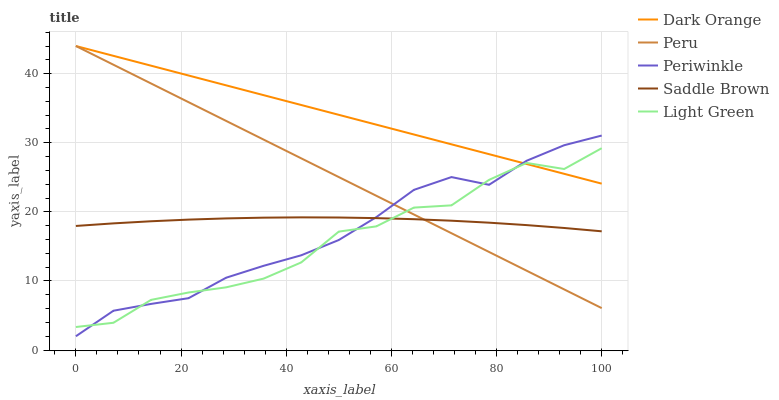Does Light Green have the minimum area under the curve?
Answer yes or no. Yes. Does Dark Orange have the maximum area under the curve?
Answer yes or no. Yes. Does Periwinkle have the minimum area under the curve?
Answer yes or no. No. Does Periwinkle have the maximum area under the curve?
Answer yes or no. No. Is Dark Orange the smoothest?
Answer yes or no. Yes. Is Light Green the roughest?
Answer yes or no. Yes. Is Periwinkle the smoothest?
Answer yes or no. No. Is Periwinkle the roughest?
Answer yes or no. No. Does Periwinkle have the lowest value?
Answer yes or no. Yes. Does Light Green have the lowest value?
Answer yes or no. No. Does Peru have the highest value?
Answer yes or no. Yes. Does Light Green have the highest value?
Answer yes or no. No. Is Saddle Brown less than Dark Orange?
Answer yes or no. Yes. Is Dark Orange greater than Saddle Brown?
Answer yes or no. Yes. Does Light Green intersect Peru?
Answer yes or no. Yes. Is Light Green less than Peru?
Answer yes or no. No. Is Light Green greater than Peru?
Answer yes or no. No. Does Saddle Brown intersect Dark Orange?
Answer yes or no. No. 